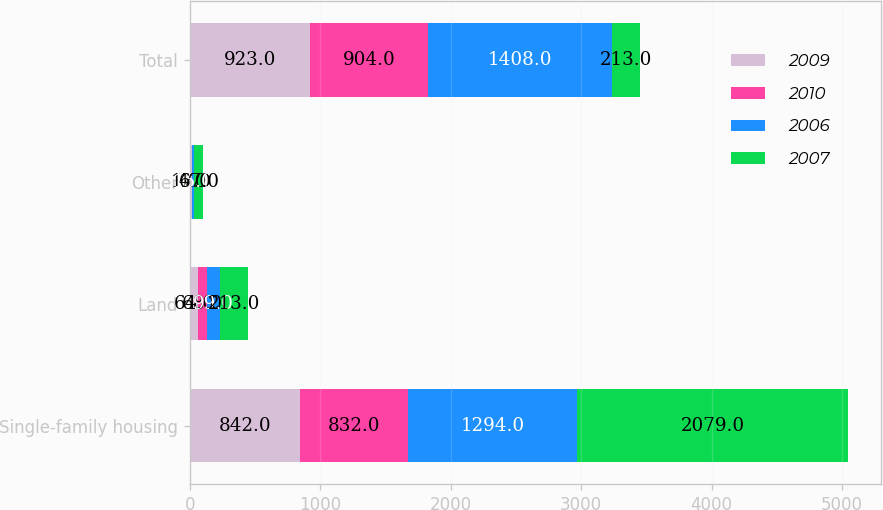Convert chart. <chart><loc_0><loc_0><loc_500><loc_500><stacked_bar_chart><ecel><fcel>Single-family housing<fcel>Land<fcel>Other<fcel>Total<nl><fcel>2009<fcel>842<fcel>64<fcel>17<fcel>923<nl><fcel>2010<fcel>832<fcel>68<fcel>4<fcel>904<nl><fcel>2006<fcel>1294<fcel>99<fcel>15<fcel>1408<nl><fcel>2007<fcel>2079<fcel>213<fcel>67<fcel>213<nl></chart> 